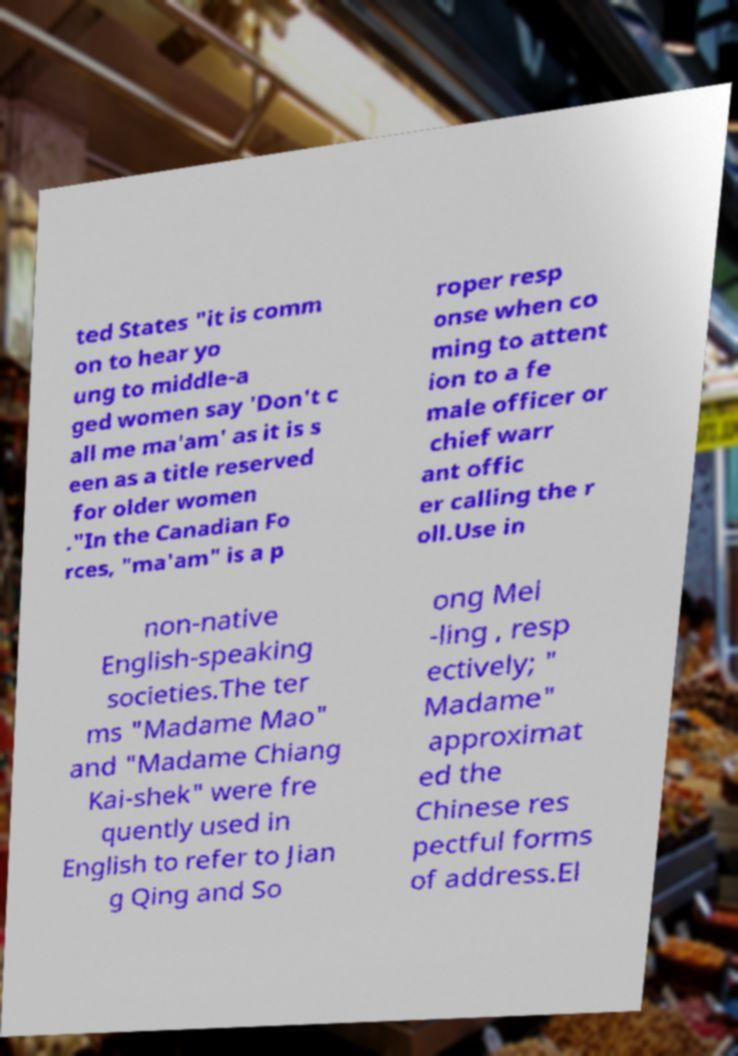What messages or text are displayed in this image? I need them in a readable, typed format. ted States "it is comm on to hear yo ung to middle-a ged women say 'Don't c all me ma'am' as it is s een as a title reserved for older women ."In the Canadian Fo rces, "ma'am" is a p roper resp onse when co ming to attent ion to a fe male officer or chief warr ant offic er calling the r oll.Use in non-native English-speaking societies.The ter ms "Madame Mao" and "Madame Chiang Kai-shek" were fre quently used in English to refer to Jian g Qing and So ong Mei -ling , resp ectively; " Madame" approximat ed the Chinese res pectful forms of address.El 